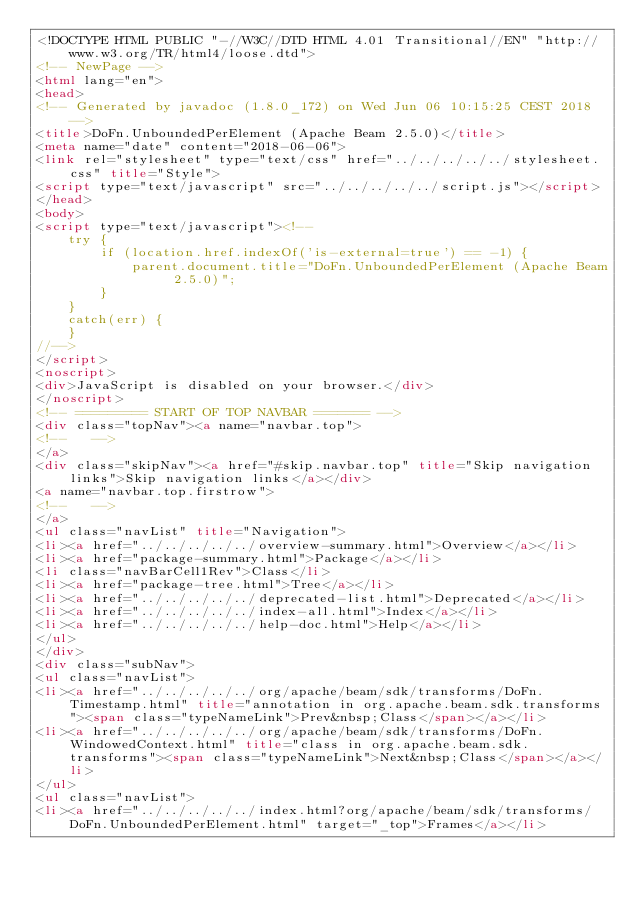Convert code to text. <code><loc_0><loc_0><loc_500><loc_500><_HTML_><!DOCTYPE HTML PUBLIC "-//W3C//DTD HTML 4.01 Transitional//EN" "http://www.w3.org/TR/html4/loose.dtd">
<!-- NewPage -->
<html lang="en">
<head>
<!-- Generated by javadoc (1.8.0_172) on Wed Jun 06 10:15:25 CEST 2018 -->
<title>DoFn.UnboundedPerElement (Apache Beam 2.5.0)</title>
<meta name="date" content="2018-06-06">
<link rel="stylesheet" type="text/css" href="../../../../../stylesheet.css" title="Style">
<script type="text/javascript" src="../../../../../script.js"></script>
</head>
<body>
<script type="text/javascript"><!--
    try {
        if (location.href.indexOf('is-external=true') == -1) {
            parent.document.title="DoFn.UnboundedPerElement (Apache Beam 2.5.0)";
        }
    }
    catch(err) {
    }
//-->
</script>
<noscript>
<div>JavaScript is disabled on your browser.</div>
</noscript>
<!-- ========= START OF TOP NAVBAR ======= -->
<div class="topNav"><a name="navbar.top">
<!--   -->
</a>
<div class="skipNav"><a href="#skip.navbar.top" title="Skip navigation links">Skip navigation links</a></div>
<a name="navbar.top.firstrow">
<!--   -->
</a>
<ul class="navList" title="Navigation">
<li><a href="../../../../../overview-summary.html">Overview</a></li>
<li><a href="package-summary.html">Package</a></li>
<li class="navBarCell1Rev">Class</li>
<li><a href="package-tree.html">Tree</a></li>
<li><a href="../../../../../deprecated-list.html">Deprecated</a></li>
<li><a href="../../../../../index-all.html">Index</a></li>
<li><a href="../../../../../help-doc.html">Help</a></li>
</ul>
</div>
<div class="subNav">
<ul class="navList">
<li><a href="../../../../../org/apache/beam/sdk/transforms/DoFn.Timestamp.html" title="annotation in org.apache.beam.sdk.transforms"><span class="typeNameLink">Prev&nbsp;Class</span></a></li>
<li><a href="../../../../../org/apache/beam/sdk/transforms/DoFn.WindowedContext.html" title="class in org.apache.beam.sdk.transforms"><span class="typeNameLink">Next&nbsp;Class</span></a></li>
</ul>
<ul class="navList">
<li><a href="../../../../../index.html?org/apache/beam/sdk/transforms/DoFn.UnboundedPerElement.html" target="_top">Frames</a></li></code> 